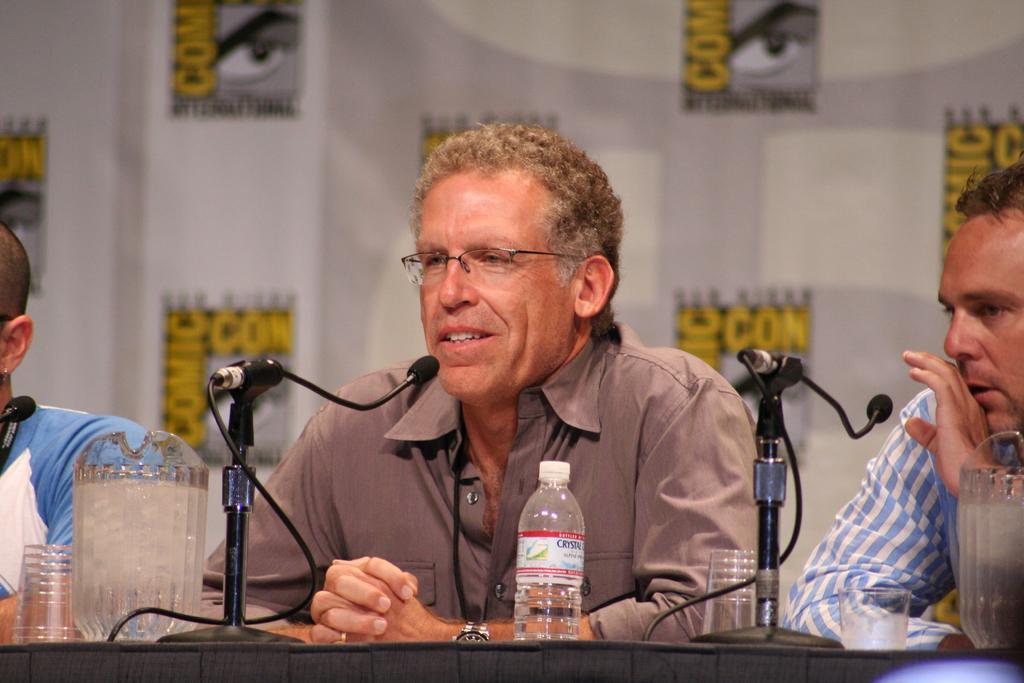How would you summarize this image in a sentence or two? In this picture I can observe three members sitting in front of the table on which I can observe cups and water bottle. One of them is wearing spectacles. There are two mics on the table. In the background there is a poster. 